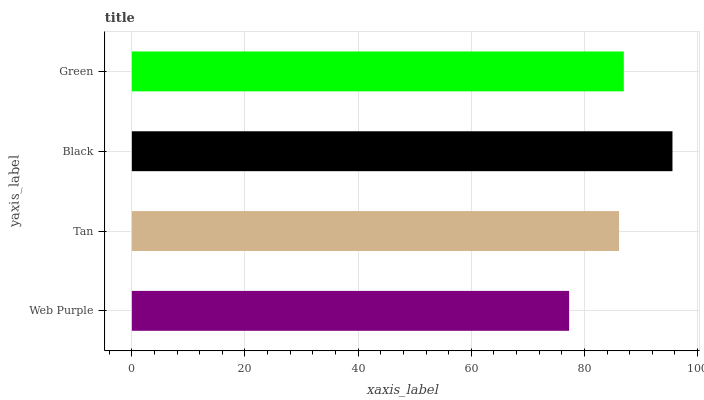Is Web Purple the minimum?
Answer yes or no. Yes. Is Black the maximum?
Answer yes or no. Yes. Is Tan the minimum?
Answer yes or no. No. Is Tan the maximum?
Answer yes or no. No. Is Tan greater than Web Purple?
Answer yes or no. Yes. Is Web Purple less than Tan?
Answer yes or no. Yes. Is Web Purple greater than Tan?
Answer yes or no. No. Is Tan less than Web Purple?
Answer yes or no. No. Is Green the high median?
Answer yes or no. Yes. Is Tan the low median?
Answer yes or no. Yes. Is Black the high median?
Answer yes or no. No. Is Black the low median?
Answer yes or no. No. 